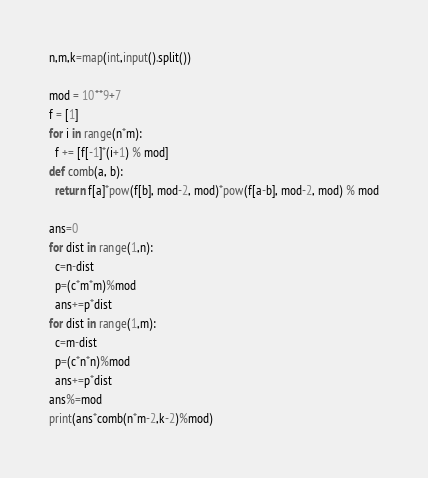Convert code to text. <code><loc_0><loc_0><loc_500><loc_500><_Python_>n,m,k=map(int,input().split())

mod = 10**9+7
f = [1]
for i in range(n*m):
  f += [f[-1]*(i+1) % mod]
def comb(a, b):
  return f[a]*pow(f[b], mod-2, mod)*pow(f[a-b], mod-2, mod) % mod

ans=0
for dist in range(1,n):
  c=n-dist
  p=(c*m*m)%mod
  ans+=p*dist
for dist in range(1,m):
  c=m-dist
  p=(c*n*n)%mod
  ans+=p*dist
ans%=mod
print(ans*comb(n*m-2,k-2)%mod)</code> 